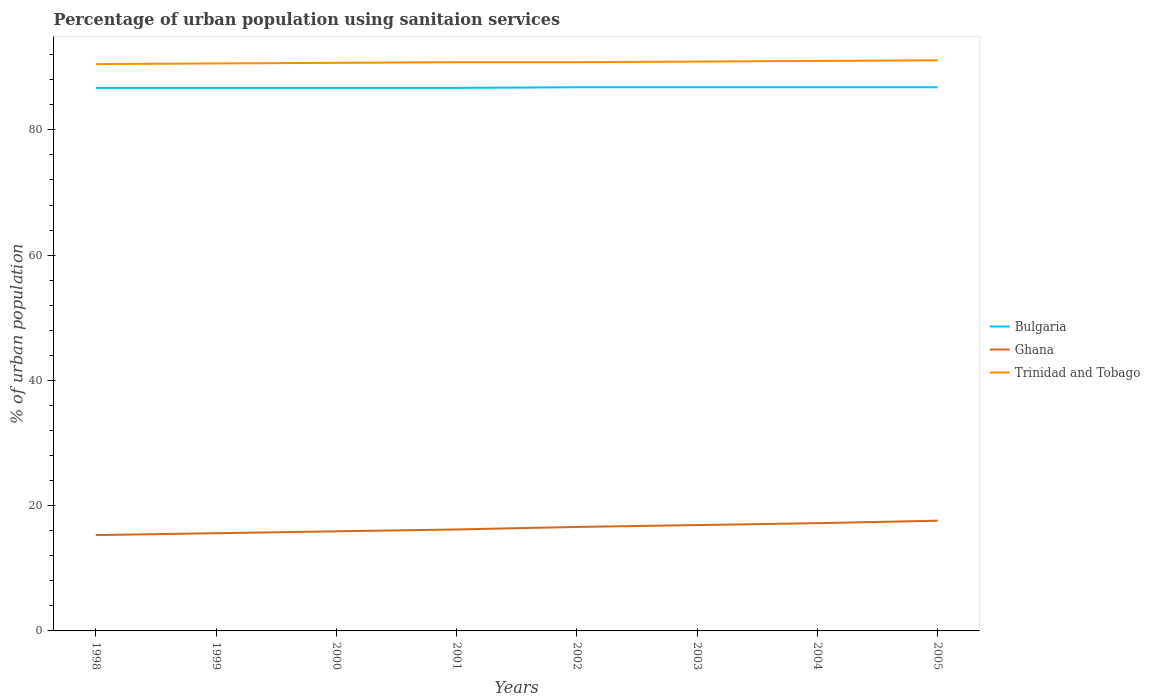How many different coloured lines are there?
Keep it short and to the point. 3. Across all years, what is the maximum percentage of urban population using sanitaion services in Ghana?
Give a very brief answer. 15.3. What is the total percentage of urban population using sanitaion services in Trinidad and Tobago in the graph?
Offer a very short reply. -0.2. What is the difference between the highest and the second highest percentage of urban population using sanitaion services in Ghana?
Your answer should be very brief. 2.3. What is the difference between the highest and the lowest percentage of urban population using sanitaion services in Bulgaria?
Your answer should be very brief. 4. How many years are there in the graph?
Your response must be concise. 8. What is the difference between two consecutive major ticks on the Y-axis?
Offer a terse response. 20. Are the values on the major ticks of Y-axis written in scientific E-notation?
Provide a short and direct response. No. Does the graph contain any zero values?
Provide a short and direct response. No. Where does the legend appear in the graph?
Make the answer very short. Center right. What is the title of the graph?
Your answer should be very brief. Percentage of urban population using sanitaion services. What is the label or title of the Y-axis?
Your answer should be very brief. % of urban population. What is the % of urban population of Bulgaria in 1998?
Your answer should be compact. 86.7. What is the % of urban population in Trinidad and Tobago in 1998?
Give a very brief answer. 90.5. What is the % of urban population in Bulgaria in 1999?
Ensure brevity in your answer.  86.7. What is the % of urban population in Ghana in 1999?
Keep it short and to the point. 15.6. What is the % of urban population in Trinidad and Tobago in 1999?
Offer a very short reply. 90.6. What is the % of urban population of Bulgaria in 2000?
Give a very brief answer. 86.7. What is the % of urban population of Ghana in 2000?
Keep it short and to the point. 15.9. What is the % of urban population of Trinidad and Tobago in 2000?
Provide a short and direct response. 90.7. What is the % of urban population in Bulgaria in 2001?
Give a very brief answer. 86.7. What is the % of urban population of Trinidad and Tobago in 2001?
Offer a very short reply. 90.8. What is the % of urban population in Bulgaria in 2002?
Your answer should be very brief. 86.8. What is the % of urban population in Trinidad and Tobago in 2002?
Provide a short and direct response. 90.8. What is the % of urban population of Bulgaria in 2003?
Offer a terse response. 86.8. What is the % of urban population in Ghana in 2003?
Offer a very short reply. 16.9. What is the % of urban population in Trinidad and Tobago in 2003?
Make the answer very short. 90.9. What is the % of urban population in Bulgaria in 2004?
Ensure brevity in your answer.  86.8. What is the % of urban population of Trinidad and Tobago in 2004?
Your response must be concise. 91. What is the % of urban population in Bulgaria in 2005?
Your response must be concise. 86.8. What is the % of urban population of Ghana in 2005?
Give a very brief answer. 17.6. What is the % of urban population in Trinidad and Tobago in 2005?
Give a very brief answer. 91.1. Across all years, what is the maximum % of urban population in Bulgaria?
Your answer should be compact. 86.8. Across all years, what is the maximum % of urban population in Ghana?
Offer a terse response. 17.6. Across all years, what is the maximum % of urban population in Trinidad and Tobago?
Your answer should be compact. 91.1. Across all years, what is the minimum % of urban population in Bulgaria?
Your answer should be very brief. 86.7. Across all years, what is the minimum % of urban population in Trinidad and Tobago?
Your response must be concise. 90.5. What is the total % of urban population of Bulgaria in the graph?
Offer a very short reply. 694. What is the total % of urban population in Ghana in the graph?
Provide a short and direct response. 131.3. What is the total % of urban population in Trinidad and Tobago in the graph?
Make the answer very short. 726.4. What is the difference between the % of urban population of Bulgaria in 1998 and that in 1999?
Your response must be concise. 0. What is the difference between the % of urban population in Ghana in 1998 and that in 2000?
Keep it short and to the point. -0.6. What is the difference between the % of urban population in Bulgaria in 1998 and that in 2001?
Give a very brief answer. 0. What is the difference between the % of urban population in Bulgaria in 1998 and that in 2002?
Your answer should be very brief. -0.1. What is the difference between the % of urban population in Bulgaria in 1998 and that in 2004?
Ensure brevity in your answer.  -0.1. What is the difference between the % of urban population of Ghana in 1998 and that in 2005?
Make the answer very short. -2.3. What is the difference between the % of urban population of Trinidad and Tobago in 1998 and that in 2005?
Provide a short and direct response. -0.6. What is the difference between the % of urban population of Bulgaria in 1999 and that in 2000?
Give a very brief answer. 0. What is the difference between the % of urban population in Trinidad and Tobago in 1999 and that in 2001?
Offer a terse response. -0.2. What is the difference between the % of urban population of Ghana in 1999 and that in 2002?
Provide a succinct answer. -1. What is the difference between the % of urban population of Trinidad and Tobago in 1999 and that in 2002?
Provide a succinct answer. -0.2. What is the difference between the % of urban population of Bulgaria in 1999 and that in 2003?
Offer a very short reply. -0.1. What is the difference between the % of urban population in Ghana in 1999 and that in 2003?
Your answer should be very brief. -1.3. What is the difference between the % of urban population in Bulgaria in 1999 and that in 2004?
Provide a short and direct response. -0.1. What is the difference between the % of urban population of Trinidad and Tobago in 1999 and that in 2004?
Offer a very short reply. -0.4. What is the difference between the % of urban population of Bulgaria in 2000 and that in 2001?
Your answer should be compact. 0. What is the difference between the % of urban population in Trinidad and Tobago in 2000 and that in 2001?
Offer a very short reply. -0.1. What is the difference between the % of urban population of Bulgaria in 2000 and that in 2002?
Provide a short and direct response. -0.1. What is the difference between the % of urban population of Trinidad and Tobago in 2000 and that in 2002?
Give a very brief answer. -0.1. What is the difference between the % of urban population in Trinidad and Tobago in 2000 and that in 2003?
Your response must be concise. -0.2. What is the difference between the % of urban population in Ghana in 2000 and that in 2004?
Provide a succinct answer. -1.3. What is the difference between the % of urban population in Bulgaria in 2000 and that in 2005?
Your answer should be very brief. -0.1. What is the difference between the % of urban population in Trinidad and Tobago in 2000 and that in 2005?
Give a very brief answer. -0.4. What is the difference between the % of urban population in Bulgaria in 2001 and that in 2003?
Give a very brief answer. -0.1. What is the difference between the % of urban population of Ghana in 2001 and that in 2003?
Your answer should be very brief. -0.7. What is the difference between the % of urban population of Trinidad and Tobago in 2001 and that in 2004?
Ensure brevity in your answer.  -0.2. What is the difference between the % of urban population of Ghana in 2001 and that in 2005?
Give a very brief answer. -1.4. What is the difference between the % of urban population of Trinidad and Tobago in 2001 and that in 2005?
Your answer should be compact. -0.3. What is the difference between the % of urban population in Bulgaria in 2002 and that in 2003?
Your answer should be very brief. 0. What is the difference between the % of urban population of Ghana in 2002 and that in 2003?
Keep it short and to the point. -0.3. What is the difference between the % of urban population in Ghana in 2002 and that in 2004?
Your response must be concise. -0.6. What is the difference between the % of urban population of Bulgaria in 2003 and that in 2004?
Offer a very short reply. 0. What is the difference between the % of urban population of Ghana in 2003 and that in 2004?
Ensure brevity in your answer.  -0.3. What is the difference between the % of urban population in Trinidad and Tobago in 2003 and that in 2004?
Give a very brief answer. -0.1. What is the difference between the % of urban population in Ghana in 2003 and that in 2005?
Make the answer very short. -0.7. What is the difference between the % of urban population of Bulgaria in 2004 and that in 2005?
Your answer should be very brief. 0. What is the difference between the % of urban population of Trinidad and Tobago in 2004 and that in 2005?
Provide a short and direct response. -0.1. What is the difference between the % of urban population of Bulgaria in 1998 and the % of urban population of Ghana in 1999?
Ensure brevity in your answer.  71.1. What is the difference between the % of urban population of Bulgaria in 1998 and the % of urban population of Trinidad and Tobago in 1999?
Offer a terse response. -3.9. What is the difference between the % of urban population of Ghana in 1998 and the % of urban population of Trinidad and Tobago in 1999?
Your response must be concise. -75.3. What is the difference between the % of urban population in Bulgaria in 1998 and the % of urban population in Ghana in 2000?
Make the answer very short. 70.8. What is the difference between the % of urban population in Ghana in 1998 and the % of urban population in Trinidad and Tobago in 2000?
Offer a very short reply. -75.4. What is the difference between the % of urban population of Bulgaria in 1998 and the % of urban population of Ghana in 2001?
Provide a succinct answer. 70.5. What is the difference between the % of urban population in Ghana in 1998 and the % of urban population in Trinidad and Tobago in 2001?
Ensure brevity in your answer.  -75.5. What is the difference between the % of urban population of Bulgaria in 1998 and the % of urban population of Ghana in 2002?
Provide a short and direct response. 70.1. What is the difference between the % of urban population of Ghana in 1998 and the % of urban population of Trinidad and Tobago in 2002?
Offer a terse response. -75.5. What is the difference between the % of urban population in Bulgaria in 1998 and the % of urban population in Ghana in 2003?
Give a very brief answer. 69.8. What is the difference between the % of urban population of Ghana in 1998 and the % of urban population of Trinidad and Tobago in 2003?
Provide a short and direct response. -75.6. What is the difference between the % of urban population in Bulgaria in 1998 and the % of urban population in Ghana in 2004?
Offer a terse response. 69.5. What is the difference between the % of urban population of Bulgaria in 1998 and the % of urban population of Trinidad and Tobago in 2004?
Offer a terse response. -4.3. What is the difference between the % of urban population of Ghana in 1998 and the % of urban population of Trinidad and Tobago in 2004?
Ensure brevity in your answer.  -75.7. What is the difference between the % of urban population of Bulgaria in 1998 and the % of urban population of Ghana in 2005?
Provide a succinct answer. 69.1. What is the difference between the % of urban population in Ghana in 1998 and the % of urban population in Trinidad and Tobago in 2005?
Provide a succinct answer. -75.8. What is the difference between the % of urban population in Bulgaria in 1999 and the % of urban population in Ghana in 2000?
Provide a succinct answer. 70.8. What is the difference between the % of urban population of Ghana in 1999 and the % of urban population of Trinidad and Tobago in 2000?
Make the answer very short. -75.1. What is the difference between the % of urban population in Bulgaria in 1999 and the % of urban population in Ghana in 2001?
Give a very brief answer. 70.5. What is the difference between the % of urban population in Bulgaria in 1999 and the % of urban population in Trinidad and Tobago in 2001?
Your answer should be very brief. -4.1. What is the difference between the % of urban population in Ghana in 1999 and the % of urban population in Trinidad and Tobago in 2001?
Provide a short and direct response. -75.2. What is the difference between the % of urban population of Bulgaria in 1999 and the % of urban population of Ghana in 2002?
Your answer should be compact. 70.1. What is the difference between the % of urban population in Bulgaria in 1999 and the % of urban population in Trinidad and Tobago in 2002?
Make the answer very short. -4.1. What is the difference between the % of urban population of Ghana in 1999 and the % of urban population of Trinidad and Tobago in 2002?
Provide a succinct answer. -75.2. What is the difference between the % of urban population in Bulgaria in 1999 and the % of urban population in Ghana in 2003?
Give a very brief answer. 69.8. What is the difference between the % of urban population in Ghana in 1999 and the % of urban population in Trinidad and Tobago in 2003?
Your response must be concise. -75.3. What is the difference between the % of urban population of Bulgaria in 1999 and the % of urban population of Ghana in 2004?
Provide a succinct answer. 69.5. What is the difference between the % of urban population of Bulgaria in 1999 and the % of urban population of Trinidad and Tobago in 2004?
Ensure brevity in your answer.  -4.3. What is the difference between the % of urban population of Ghana in 1999 and the % of urban population of Trinidad and Tobago in 2004?
Offer a very short reply. -75.4. What is the difference between the % of urban population of Bulgaria in 1999 and the % of urban population of Ghana in 2005?
Make the answer very short. 69.1. What is the difference between the % of urban population in Bulgaria in 1999 and the % of urban population in Trinidad and Tobago in 2005?
Provide a short and direct response. -4.4. What is the difference between the % of urban population in Ghana in 1999 and the % of urban population in Trinidad and Tobago in 2005?
Provide a succinct answer. -75.5. What is the difference between the % of urban population of Bulgaria in 2000 and the % of urban population of Ghana in 2001?
Keep it short and to the point. 70.5. What is the difference between the % of urban population of Bulgaria in 2000 and the % of urban population of Trinidad and Tobago in 2001?
Give a very brief answer. -4.1. What is the difference between the % of urban population in Ghana in 2000 and the % of urban population in Trinidad and Tobago in 2001?
Your answer should be compact. -74.9. What is the difference between the % of urban population of Bulgaria in 2000 and the % of urban population of Ghana in 2002?
Keep it short and to the point. 70.1. What is the difference between the % of urban population in Bulgaria in 2000 and the % of urban population in Trinidad and Tobago in 2002?
Your response must be concise. -4.1. What is the difference between the % of urban population in Ghana in 2000 and the % of urban population in Trinidad and Tobago in 2002?
Your answer should be very brief. -74.9. What is the difference between the % of urban population in Bulgaria in 2000 and the % of urban population in Ghana in 2003?
Offer a terse response. 69.8. What is the difference between the % of urban population in Ghana in 2000 and the % of urban population in Trinidad and Tobago in 2003?
Provide a succinct answer. -75. What is the difference between the % of urban population in Bulgaria in 2000 and the % of urban population in Ghana in 2004?
Your answer should be very brief. 69.5. What is the difference between the % of urban population of Ghana in 2000 and the % of urban population of Trinidad and Tobago in 2004?
Offer a very short reply. -75.1. What is the difference between the % of urban population of Bulgaria in 2000 and the % of urban population of Ghana in 2005?
Ensure brevity in your answer.  69.1. What is the difference between the % of urban population of Ghana in 2000 and the % of urban population of Trinidad and Tobago in 2005?
Offer a very short reply. -75.2. What is the difference between the % of urban population of Bulgaria in 2001 and the % of urban population of Ghana in 2002?
Give a very brief answer. 70.1. What is the difference between the % of urban population in Ghana in 2001 and the % of urban population in Trinidad and Tobago in 2002?
Offer a very short reply. -74.6. What is the difference between the % of urban population in Bulgaria in 2001 and the % of urban population in Ghana in 2003?
Ensure brevity in your answer.  69.8. What is the difference between the % of urban population of Bulgaria in 2001 and the % of urban population of Trinidad and Tobago in 2003?
Your response must be concise. -4.2. What is the difference between the % of urban population in Ghana in 2001 and the % of urban population in Trinidad and Tobago in 2003?
Keep it short and to the point. -74.7. What is the difference between the % of urban population in Bulgaria in 2001 and the % of urban population in Ghana in 2004?
Your answer should be very brief. 69.5. What is the difference between the % of urban population in Ghana in 2001 and the % of urban population in Trinidad and Tobago in 2004?
Keep it short and to the point. -74.8. What is the difference between the % of urban population in Bulgaria in 2001 and the % of urban population in Ghana in 2005?
Your response must be concise. 69.1. What is the difference between the % of urban population in Bulgaria in 2001 and the % of urban population in Trinidad and Tobago in 2005?
Keep it short and to the point. -4.4. What is the difference between the % of urban population in Ghana in 2001 and the % of urban population in Trinidad and Tobago in 2005?
Your response must be concise. -74.9. What is the difference between the % of urban population in Bulgaria in 2002 and the % of urban population in Ghana in 2003?
Offer a very short reply. 69.9. What is the difference between the % of urban population of Ghana in 2002 and the % of urban population of Trinidad and Tobago in 2003?
Ensure brevity in your answer.  -74.3. What is the difference between the % of urban population of Bulgaria in 2002 and the % of urban population of Ghana in 2004?
Provide a short and direct response. 69.6. What is the difference between the % of urban population of Ghana in 2002 and the % of urban population of Trinidad and Tobago in 2004?
Ensure brevity in your answer.  -74.4. What is the difference between the % of urban population of Bulgaria in 2002 and the % of urban population of Ghana in 2005?
Keep it short and to the point. 69.2. What is the difference between the % of urban population in Ghana in 2002 and the % of urban population in Trinidad and Tobago in 2005?
Give a very brief answer. -74.5. What is the difference between the % of urban population in Bulgaria in 2003 and the % of urban population in Ghana in 2004?
Your answer should be very brief. 69.6. What is the difference between the % of urban population of Ghana in 2003 and the % of urban population of Trinidad and Tobago in 2004?
Your answer should be compact. -74.1. What is the difference between the % of urban population of Bulgaria in 2003 and the % of urban population of Ghana in 2005?
Keep it short and to the point. 69.2. What is the difference between the % of urban population in Bulgaria in 2003 and the % of urban population in Trinidad and Tobago in 2005?
Make the answer very short. -4.3. What is the difference between the % of urban population in Ghana in 2003 and the % of urban population in Trinidad and Tobago in 2005?
Ensure brevity in your answer.  -74.2. What is the difference between the % of urban population in Bulgaria in 2004 and the % of urban population in Ghana in 2005?
Provide a succinct answer. 69.2. What is the difference between the % of urban population of Bulgaria in 2004 and the % of urban population of Trinidad and Tobago in 2005?
Provide a succinct answer. -4.3. What is the difference between the % of urban population of Ghana in 2004 and the % of urban population of Trinidad and Tobago in 2005?
Provide a succinct answer. -73.9. What is the average % of urban population of Bulgaria per year?
Make the answer very short. 86.75. What is the average % of urban population in Ghana per year?
Give a very brief answer. 16.41. What is the average % of urban population of Trinidad and Tobago per year?
Ensure brevity in your answer.  90.8. In the year 1998, what is the difference between the % of urban population of Bulgaria and % of urban population of Ghana?
Provide a succinct answer. 71.4. In the year 1998, what is the difference between the % of urban population in Bulgaria and % of urban population in Trinidad and Tobago?
Make the answer very short. -3.8. In the year 1998, what is the difference between the % of urban population of Ghana and % of urban population of Trinidad and Tobago?
Your answer should be compact. -75.2. In the year 1999, what is the difference between the % of urban population of Bulgaria and % of urban population of Ghana?
Make the answer very short. 71.1. In the year 1999, what is the difference between the % of urban population of Ghana and % of urban population of Trinidad and Tobago?
Your answer should be very brief. -75. In the year 2000, what is the difference between the % of urban population in Bulgaria and % of urban population in Ghana?
Keep it short and to the point. 70.8. In the year 2000, what is the difference between the % of urban population of Ghana and % of urban population of Trinidad and Tobago?
Keep it short and to the point. -74.8. In the year 2001, what is the difference between the % of urban population of Bulgaria and % of urban population of Ghana?
Your answer should be compact. 70.5. In the year 2001, what is the difference between the % of urban population in Bulgaria and % of urban population in Trinidad and Tobago?
Ensure brevity in your answer.  -4.1. In the year 2001, what is the difference between the % of urban population of Ghana and % of urban population of Trinidad and Tobago?
Your response must be concise. -74.6. In the year 2002, what is the difference between the % of urban population in Bulgaria and % of urban population in Ghana?
Make the answer very short. 70.2. In the year 2002, what is the difference between the % of urban population of Ghana and % of urban population of Trinidad and Tobago?
Your answer should be compact. -74.2. In the year 2003, what is the difference between the % of urban population of Bulgaria and % of urban population of Ghana?
Provide a succinct answer. 69.9. In the year 2003, what is the difference between the % of urban population of Ghana and % of urban population of Trinidad and Tobago?
Offer a terse response. -74. In the year 2004, what is the difference between the % of urban population of Bulgaria and % of urban population of Ghana?
Your answer should be very brief. 69.6. In the year 2004, what is the difference between the % of urban population in Bulgaria and % of urban population in Trinidad and Tobago?
Make the answer very short. -4.2. In the year 2004, what is the difference between the % of urban population in Ghana and % of urban population in Trinidad and Tobago?
Your answer should be very brief. -73.8. In the year 2005, what is the difference between the % of urban population of Bulgaria and % of urban population of Ghana?
Keep it short and to the point. 69.2. In the year 2005, what is the difference between the % of urban population in Ghana and % of urban population in Trinidad and Tobago?
Your answer should be compact. -73.5. What is the ratio of the % of urban population in Ghana in 1998 to that in 1999?
Give a very brief answer. 0.98. What is the ratio of the % of urban population of Bulgaria in 1998 to that in 2000?
Ensure brevity in your answer.  1. What is the ratio of the % of urban population in Ghana in 1998 to that in 2000?
Ensure brevity in your answer.  0.96. What is the ratio of the % of urban population of Trinidad and Tobago in 1998 to that in 2000?
Offer a very short reply. 1. What is the ratio of the % of urban population of Ghana in 1998 to that in 2002?
Give a very brief answer. 0.92. What is the ratio of the % of urban population of Trinidad and Tobago in 1998 to that in 2002?
Offer a very short reply. 1. What is the ratio of the % of urban population in Bulgaria in 1998 to that in 2003?
Your response must be concise. 1. What is the ratio of the % of urban population in Ghana in 1998 to that in 2003?
Your response must be concise. 0.91. What is the ratio of the % of urban population in Trinidad and Tobago in 1998 to that in 2003?
Your answer should be compact. 1. What is the ratio of the % of urban population in Ghana in 1998 to that in 2004?
Make the answer very short. 0.89. What is the ratio of the % of urban population of Trinidad and Tobago in 1998 to that in 2004?
Provide a short and direct response. 0.99. What is the ratio of the % of urban population in Bulgaria in 1998 to that in 2005?
Give a very brief answer. 1. What is the ratio of the % of urban population of Ghana in 1998 to that in 2005?
Make the answer very short. 0.87. What is the ratio of the % of urban population in Ghana in 1999 to that in 2000?
Provide a short and direct response. 0.98. What is the ratio of the % of urban population of Ghana in 1999 to that in 2001?
Your answer should be very brief. 0.96. What is the ratio of the % of urban population in Trinidad and Tobago in 1999 to that in 2001?
Keep it short and to the point. 1. What is the ratio of the % of urban population in Bulgaria in 1999 to that in 2002?
Your answer should be very brief. 1. What is the ratio of the % of urban population of Ghana in 1999 to that in 2002?
Ensure brevity in your answer.  0.94. What is the ratio of the % of urban population in Bulgaria in 1999 to that in 2003?
Give a very brief answer. 1. What is the ratio of the % of urban population in Ghana in 1999 to that in 2003?
Give a very brief answer. 0.92. What is the ratio of the % of urban population in Trinidad and Tobago in 1999 to that in 2003?
Your answer should be compact. 1. What is the ratio of the % of urban population in Bulgaria in 1999 to that in 2004?
Offer a very short reply. 1. What is the ratio of the % of urban population in Ghana in 1999 to that in 2004?
Give a very brief answer. 0.91. What is the ratio of the % of urban population in Trinidad and Tobago in 1999 to that in 2004?
Ensure brevity in your answer.  1. What is the ratio of the % of urban population of Ghana in 1999 to that in 2005?
Provide a succinct answer. 0.89. What is the ratio of the % of urban population of Trinidad and Tobago in 1999 to that in 2005?
Ensure brevity in your answer.  0.99. What is the ratio of the % of urban population of Bulgaria in 2000 to that in 2001?
Keep it short and to the point. 1. What is the ratio of the % of urban population of Ghana in 2000 to that in 2001?
Offer a very short reply. 0.98. What is the ratio of the % of urban population in Trinidad and Tobago in 2000 to that in 2001?
Provide a short and direct response. 1. What is the ratio of the % of urban population in Ghana in 2000 to that in 2002?
Your answer should be compact. 0.96. What is the ratio of the % of urban population of Trinidad and Tobago in 2000 to that in 2002?
Give a very brief answer. 1. What is the ratio of the % of urban population in Ghana in 2000 to that in 2003?
Your answer should be compact. 0.94. What is the ratio of the % of urban population in Ghana in 2000 to that in 2004?
Offer a very short reply. 0.92. What is the ratio of the % of urban population of Bulgaria in 2000 to that in 2005?
Make the answer very short. 1. What is the ratio of the % of urban population in Ghana in 2000 to that in 2005?
Your answer should be very brief. 0.9. What is the ratio of the % of urban population in Ghana in 2001 to that in 2002?
Your answer should be very brief. 0.98. What is the ratio of the % of urban population of Trinidad and Tobago in 2001 to that in 2002?
Provide a short and direct response. 1. What is the ratio of the % of urban population in Ghana in 2001 to that in 2003?
Give a very brief answer. 0.96. What is the ratio of the % of urban population of Bulgaria in 2001 to that in 2004?
Your answer should be very brief. 1. What is the ratio of the % of urban population of Ghana in 2001 to that in 2004?
Offer a very short reply. 0.94. What is the ratio of the % of urban population of Trinidad and Tobago in 2001 to that in 2004?
Provide a succinct answer. 1. What is the ratio of the % of urban population in Bulgaria in 2001 to that in 2005?
Provide a short and direct response. 1. What is the ratio of the % of urban population of Ghana in 2001 to that in 2005?
Keep it short and to the point. 0.92. What is the ratio of the % of urban population of Ghana in 2002 to that in 2003?
Your answer should be very brief. 0.98. What is the ratio of the % of urban population of Trinidad and Tobago in 2002 to that in 2003?
Your answer should be very brief. 1. What is the ratio of the % of urban population of Ghana in 2002 to that in 2004?
Provide a short and direct response. 0.97. What is the ratio of the % of urban population in Ghana in 2002 to that in 2005?
Your answer should be very brief. 0.94. What is the ratio of the % of urban population of Ghana in 2003 to that in 2004?
Provide a succinct answer. 0.98. What is the ratio of the % of urban population of Ghana in 2003 to that in 2005?
Your answer should be compact. 0.96. What is the ratio of the % of urban population of Bulgaria in 2004 to that in 2005?
Give a very brief answer. 1. What is the ratio of the % of urban population of Ghana in 2004 to that in 2005?
Offer a very short reply. 0.98. What is the ratio of the % of urban population in Trinidad and Tobago in 2004 to that in 2005?
Make the answer very short. 1. What is the difference between the highest and the second highest % of urban population of Bulgaria?
Your answer should be compact. 0. What is the difference between the highest and the second highest % of urban population in Ghana?
Your answer should be compact. 0.4. What is the difference between the highest and the lowest % of urban population in Bulgaria?
Make the answer very short. 0.1. 